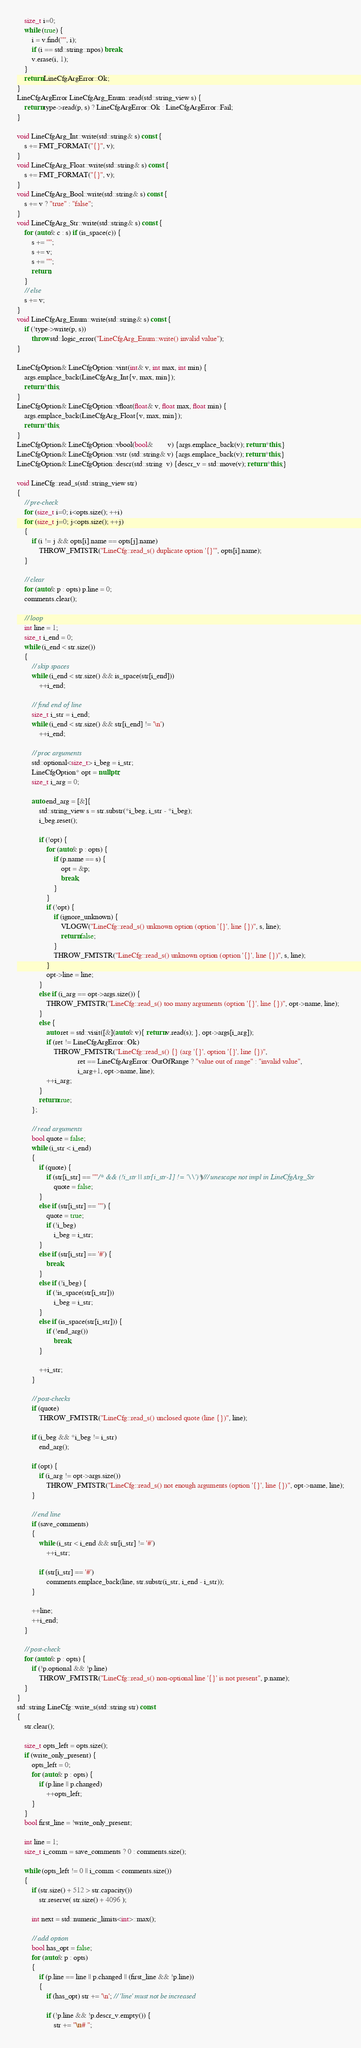<code> <loc_0><loc_0><loc_500><loc_500><_C++_>	size_t i=0;
	while (true) {
		i = v.find('"', i);
		if (i == std::string::npos) break;
		v.erase(i, 1);
	}
	return LineCfgArgError::Ok;
}
LineCfgArgError LineCfgArg_Enum::read(std::string_view s) {
	return type->read(p, s) ? LineCfgArgError::Ok : LineCfgArgError::Fail;
}

void LineCfgArg_Int::write(std::string& s) const {
	s += FMT_FORMAT("{}", v);
}
void LineCfgArg_Float::write(std::string& s) const {
	s += FMT_FORMAT("{}", v);
}
void LineCfgArg_Bool::write(std::string& s) const {
	s += v ? "true" : "false";
}
void LineCfgArg_Str::write(std::string& s) const {
	for (auto& c : s) if (is_space(c)) {
		s += '"';
		s += v;
		s += '"';
		return;
	}
	// else
	s += v;
}
void LineCfgArg_Enum::write(std::string& s) const {
	if (!type->write(p, s))
		throw std::logic_error("LineCfgArg_Enum::write() invalid value");
}

LineCfgOption& LineCfgOption::vint(int& v, int max, int min) {
	args.emplace_back(LineCfgArg_Int{v, max, min});
	return *this;
}
LineCfgOption& LineCfgOption::vfloat(float& v, float max, float min) {
	args.emplace_back(LineCfgArg_Float{v, max, min});
	return *this;
}
LineCfgOption& LineCfgOption::vbool(bool&        v) {args.emplace_back(v); return *this;}
LineCfgOption& LineCfgOption::vstr (std::string& v) {args.emplace_back(v); return *this;}
LineCfgOption& LineCfgOption::descr(std::string  v) {descr_v = std::move(v); return *this;}

void LineCfg::read_s(std::string_view str)
{
	// pre-check
	for (size_t i=0; i<opts.size(); ++i)
	for (size_t j=0; j<opts.size(); ++j)
	{
		if (i != j && opts[i].name == opts[j].name)
			THROW_FMTSTR("LineCfg::read_s() duplicate option '{}'", opts[i].name);
	}
	
	// clear
	for (auto& p : opts) p.line = 0;
	comments.clear();
	
	// loop
	int line = 1;
	size_t i_end = 0;
	while (i_end < str.size())
	{
		// skip spaces
		while (i_end < str.size() && is_space(str[i_end]))
			++i_end;
		
		// find end of line
		size_t i_str = i_end;
		while (i_end < str.size() && str[i_end] != '\n')
			++i_end;
		
		// proc arguments
		std::optional<size_t> i_beg = i_str;
		LineCfgOption* opt = nullptr;
		size_t i_arg = 0;
		
		auto end_arg = [&]{
			std::string_view s = str.substr(*i_beg, i_str - *i_beg);
			i_beg.reset();
			
			if (!opt) {
				for (auto& p : opts) {
					if (p.name == s) {
						opt = &p;
						break;
					}
				}
				if (!opt) {
					if (ignore_unknown) {
						VLOGW("LineCfg::read_s() unknown option (option '{}', line {})", s, line);
						return false;
					}
					THROW_FMTSTR("LineCfg::read_s() unknown option (option '{}', line {})", s, line);
				}
				opt->line = line;
			}
			else if (i_arg == opt->args.size()) {
				THROW_FMTSTR("LineCfg::read_s() too many arguments (option '{}', line {})", opt->name, line);
			}
			else {
				auto ret = std::visit([&](auto& v){ return v.read(s); }, opt->args[i_arg]);
				if (ret != LineCfgArgError::Ok)
					THROW_FMTSTR("LineCfg::read_s() {} (arg '{}', option '{}', line {})",
					             ret == LineCfgArgError::OutOfRange ? "value out of range" : "invalid value",
					             i_arg+1, opt->name, line);
				++i_arg;
			}
			return true;
		};
		
		// read arguments
		bool quote = false;
		while (i_str < i_end)
		{
			if (quote) {
				if (str[i_str] == '"'/* && (!i_str || str[i_str-1] != '\\')*/) // unescape not impl in LineCfgArg_Str
					quote = false;
			}
			else if (str[i_str] == '"') {
				quote = true;
				if (!i_beg)
					i_beg = i_str;
			}
			else if (str[i_str] == '#') {
				break;
			}
			else if (!i_beg) {
				if (!is_space(str[i_str]))
					i_beg = i_str;
			}
			else if (is_space(str[i_str])) {
				if (!end_arg())
					break;
			}
			
			++i_str;
		}
		
		// post-checks
		if (quote)
			THROW_FMTSTR("LineCfg::read_s() unclosed quote (line {})", line);
		
		if (i_beg && *i_beg != i_str)
			end_arg();
		
		if (opt) {
			if (i_arg != opt->args.size())
				THROW_FMTSTR("LineCfg::read_s() not enough arguments (option '{}', line {})", opt->name, line);
		}
		
		// end line
		if (save_comments)
		{
			while (i_str < i_end && str[i_str] != '#')
				++i_str;
			
			if (str[i_str] == '#')
				comments.emplace_back(line, str.substr(i_str, i_end - i_str));
		}
		
		++line;
		++i_end;
	}
	
	// post-check
	for (auto& p : opts) {
		if (!p.optional && !p.line)
			THROW_FMTSTR("LineCfg::read_s() non-optional line '{}' is not present", p.name);
	}
}
std::string LineCfg::write_s(std::string str) const
{
	str.clear();
	
	size_t opts_left = opts.size();
	if (write_only_present) {
		opts_left = 0;
		for (auto& p : opts) {
			if (p.line || p.changed)
				++opts_left;
		}
	}
	bool first_line = !write_only_present;
	
	int line = 1;
	size_t i_comm = save_comments ? 0 : comments.size();
	
	while (opts_left != 0 || i_comm < comments.size())
	{
		if (str.size() + 512 > str.capacity())
			str.reserve( str.size() + 4096 );
		
		int next = std::numeric_limits<int>::max();
		
		// add option
		bool has_opt = false;
		for (auto& p : opts)
		{
			if (p.line == line || p.changed || (first_line && !p.line))
			{
				if (has_opt) str += '\n'; // 'line' must not be increased
				
				if (!p.line && !p.descr_v.empty()) {
					str += "\n# ";</code> 